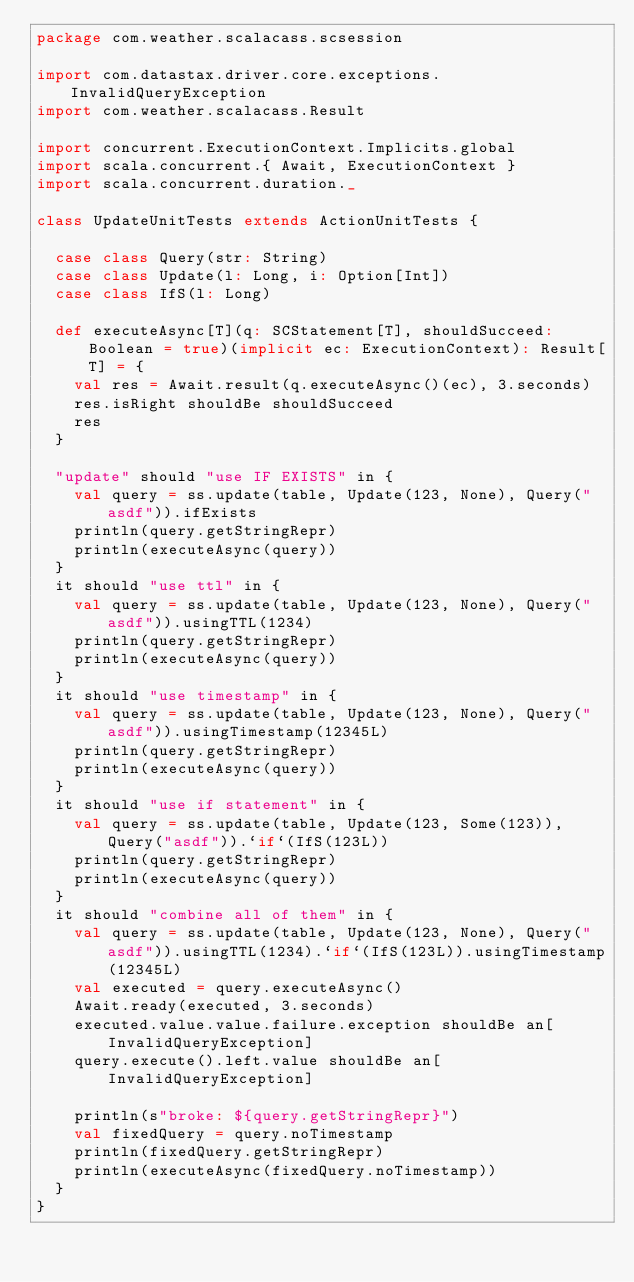<code> <loc_0><loc_0><loc_500><loc_500><_Scala_>package com.weather.scalacass.scsession

import com.datastax.driver.core.exceptions.InvalidQueryException
import com.weather.scalacass.Result

import concurrent.ExecutionContext.Implicits.global
import scala.concurrent.{ Await, ExecutionContext }
import scala.concurrent.duration._

class UpdateUnitTests extends ActionUnitTests {

  case class Query(str: String)
  case class Update(l: Long, i: Option[Int])
  case class IfS(l: Long)

  def executeAsync[T](q: SCStatement[T], shouldSucceed: Boolean = true)(implicit ec: ExecutionContext): Result[T] = {
    val res = Await.result(q.executeAsync()(ec), 3.seconds)
    res.isRight shouldBe shouldSucceed
    res
  }

  "update" should "use IF EXISTS" in {
    val query = ss.update(table, Update(123, None), Query("asdf")).ifExists
    println(query.getStringRepr)
    println(executeAsync(query))
  }
  it should "use ttl" in {
    val query = ss.update(table, Update(123, None), Query("asdf")).usingTTL(1234)
    println(query.getStringRepr)
    println(executeAsync(query))
  }
  it should "use timestamp" in {
    val query = ss.update(table, Update(123, None), Query("asdf")).usingTimestamp(12345L)
    println(query.getStringRepr)
    println(executeAsync(query))
  }
  it should "use if statement" in {
    val query = ss.update(table, Update(123, Some(123)), Query("asdf")).`if`(IfS(123L))
    println(query.getStringRepr)
    println(executeAsync(query))
  }
  it should "combine all of them" in {
    val query = ss.update(table, Update(123, None), Query("asdf")).usingTTL(1234).`if`(IfS(123L)).usingTimestamp(12345L)
    val executed = query.executeAsync()
    Await.ready(executed, 3.seconds)
    executed.value.value.failure.exception shouldBe an[InvalidQueryException]
    query.execute().left.value shouldBe an[InvalidQueryException]

    println(s"broke: ${query.getStringRepr}")
    val fixedQuery = query.noTimestamp
    println(fixedQuery.getStringRepr)
    println(executeAsync(fixedQuery.noTimestamp))
  }
}
</code> 